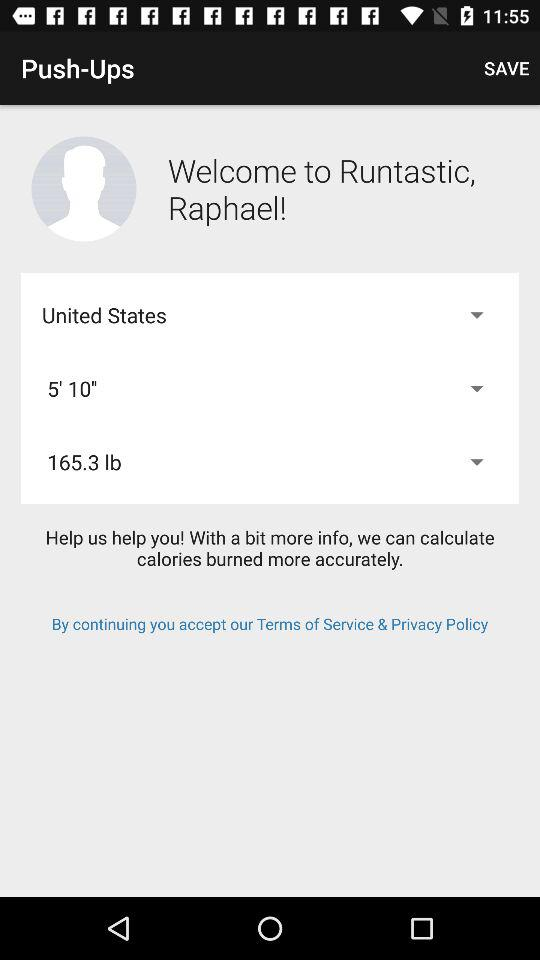What is the name of the company? The name of the company is "Runtastic". 